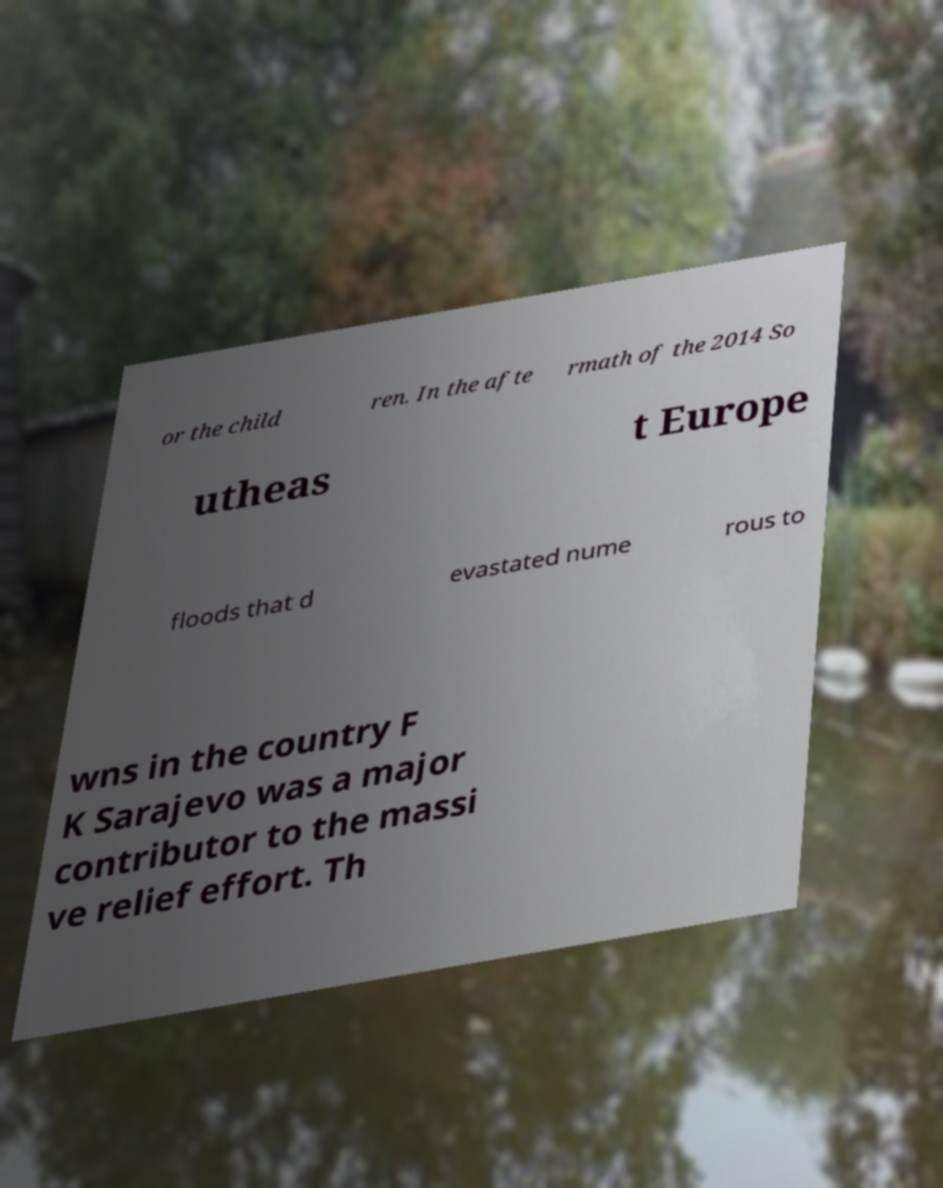Please read and relay the text visible in this image. What does it say? or the child ren. In the afte rmath of the 2014 So utheas t Europe floods that d evastated nume rous to wns in the country F K Sarajevo was a major contributor to the massi ve relief effort. Th 